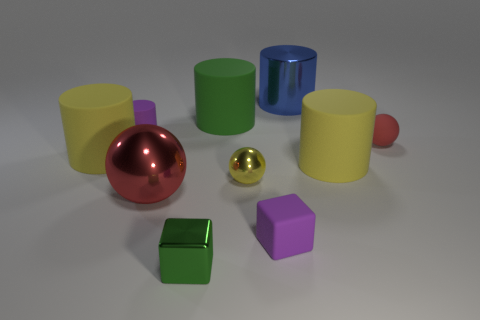Subtract all large shiny balls. How many balls are left? 2 Add 6 green metal spheres. How many green metal spheres exist? 6 Subtract all purple cylinders. How many cylinders are left? 4 Subtract 1 purple blocks. How many objects are left? 9 Subtract all spheres. How many objects are left? 7 Subtract 3 spheres. How many spheres are left? 0 Subtract all blue cylinders. Subtract all gray balls. How many cylinders are left? 4 Subtract all gray cylinders. How many blue blocks are left? 0 Subtract all big green cylinders. Subtract all red matte objects. How many objects are left? 8 Add 1 small matte objects. How many small matte objects are left? 4 